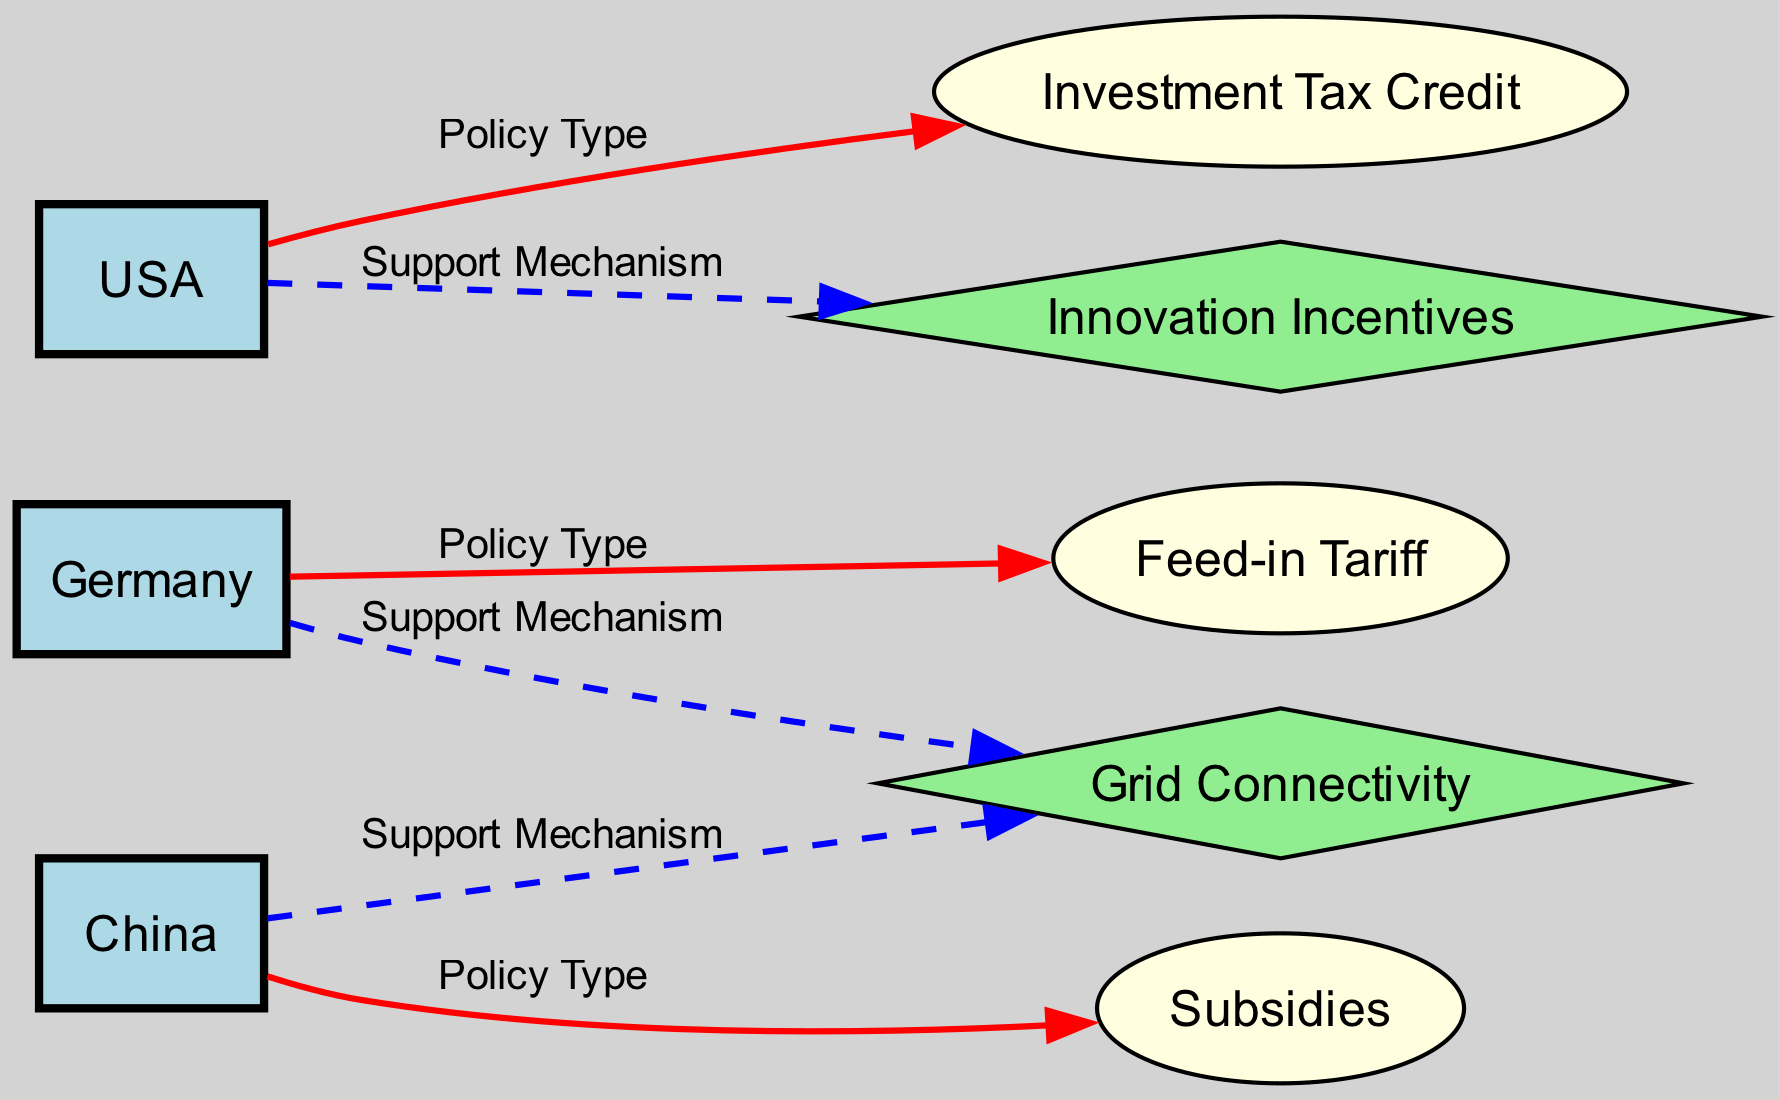What is the policy type for Germany? The diagram shows that Germany is connected to the "Feed-in Tariff" node with the relationship label "Policy Type." This indicates that the policy type implemented in Germany is the Feed-in Tariff.
Answer: Feed-in Tariff Which country is associated with Investment Tax Credit? The diagram indicates that the USA is connected to the "Investment Tax Credit" node with the relationship label "Policy Type." This means that the USA uses Investment Tax Credit as its policy type.
Answer: USA How many nodes are present in the diagram? The diagram lists a total of 8 distinct nodes: Germany, USA, China, Feed-in Tariff, Investment Tax Credit, Subsidies, Grid Connectivity, and Innovation Incentives, which adds up to 8.
Answer: 8 What support mechanism is used in China? The diagram illustrates that China links to the "Grid Connectivity" node with the relationship labeled "Support Mechanism." Thus, the support mechanism utilized in China is Grid Connectivity.
Answer: Grid Connectivity Which country utilizes both Grid Connectivity and Innovation Incentives? In the diagram, Germany and China both support Grid Connectivity, while the USA utilizes Innovation Incentives. Therefore, no single country utilizes both specified mechanisms.
Answer: None Which policy type connects China and Germany in the diagram? The diagram shows that China is connected to "Subsidies" as its policy type, while Germany is connected to "Feed-in Tariff." There is no direct connection of the same policy type between China and Germany.
Answer: None What type of edge connects the USA to Innovation Incentives? The edge from the USA to Innovation Incentives is labeled with "Support Mechanism," indicating that this is a type of support mechanism in the diagram.
Answer: Support Mechanism Which country has a dashed edge connecting it to Grid Connectivity? The diagram has a dashed edge from Germany to Grid Connectivity, indicating that they are linked by a support mechanism type relationship, which is represented by the dashed line.
Answer: Germany What color are the nodes representing countries in the diagram? According to the diagram, the nodes representing countries (Germany, USA, and China) are filled with light blue color.
Answer: Light blue 